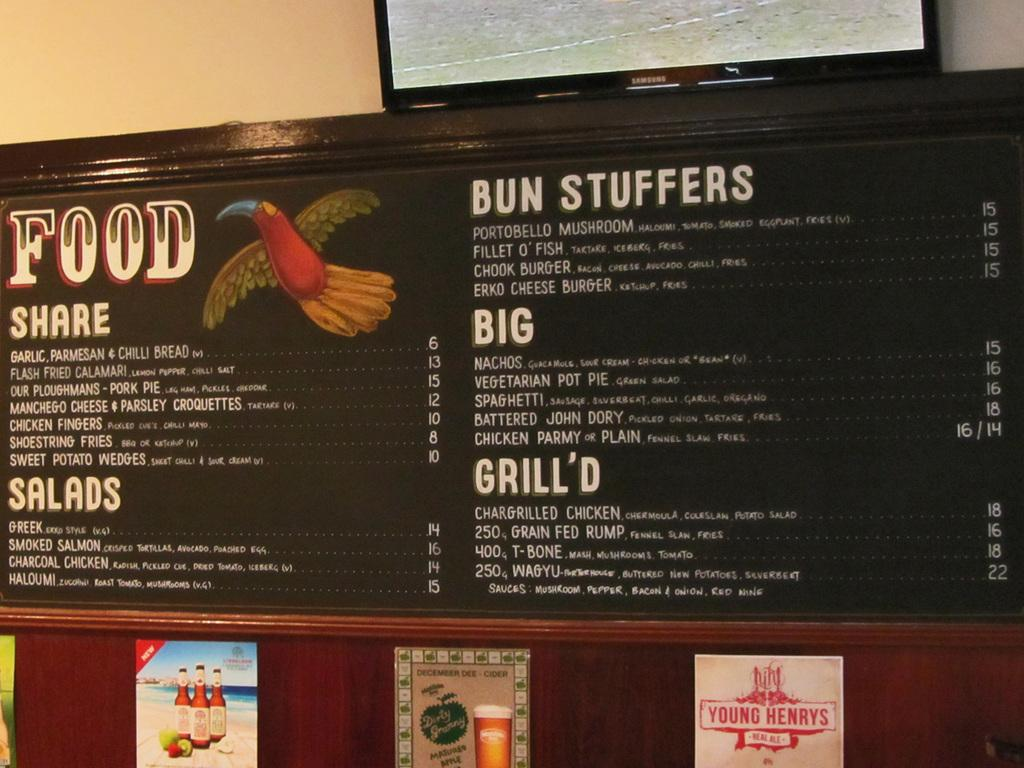<image>
Share a concise interpretation of the image provided. A menu is on a wall that says Bun Stuffers and has a TV above it. 